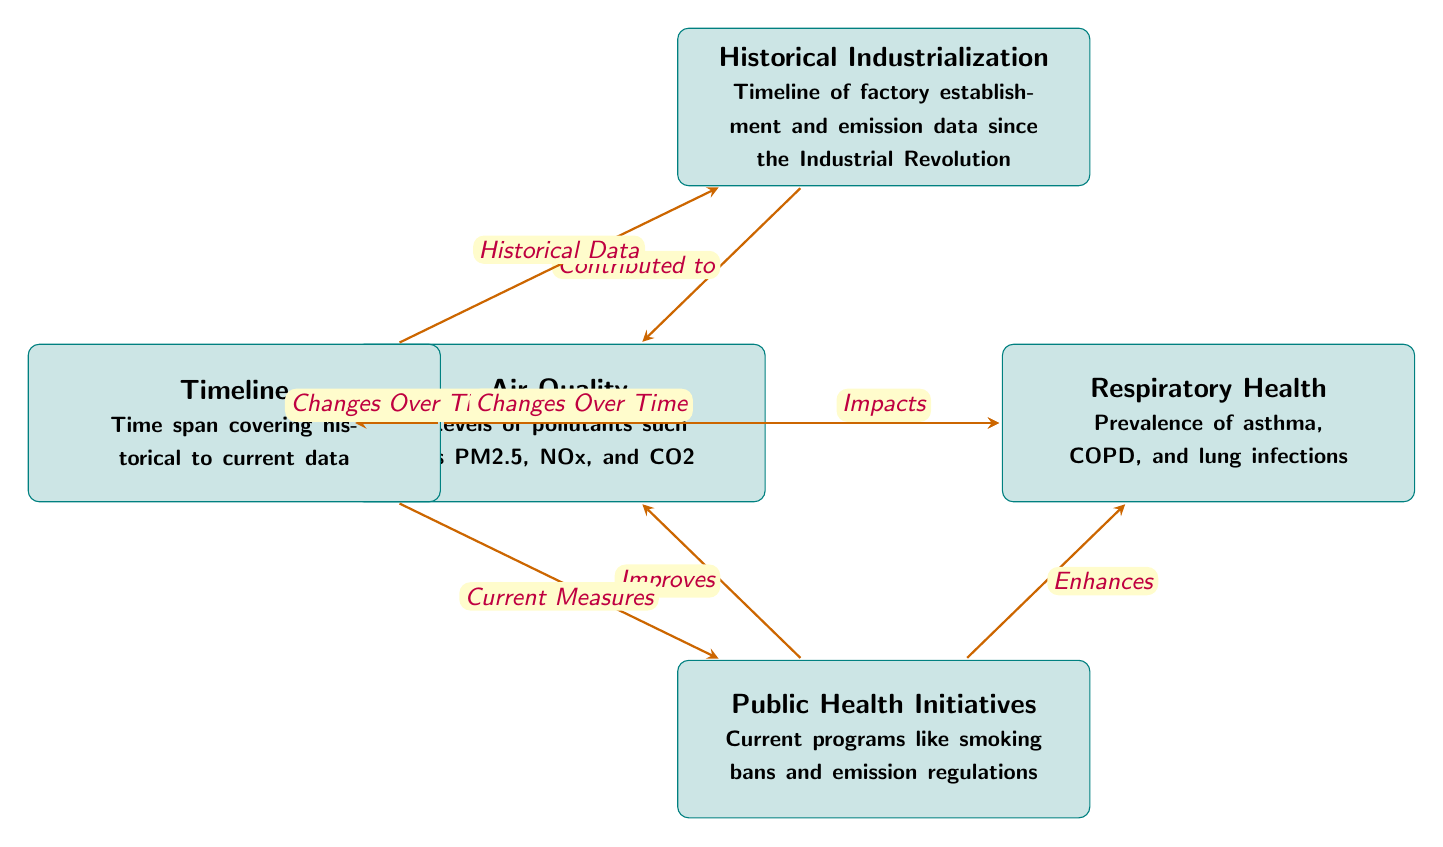What does the "Air Quality" box represent? The "Air Quality" box represents the levels of pollutants such as PM2.5, NOx, and CO2, indicating the primary focus of air quality measurement in relation to health.
Answer: Levels of pollutants such as PM2.5, NOx, and CO2 What is the impact of air quality on respiratory health? The diagram indicates that air quality impacts respiratory health, specifically showing a direct relationship from the "Air Quality" box to the "Respiratory Health" box labeled as "Impacts".
Answer: Impacts How many types of historical data are referenced in the diagram? The diagram references one type of historical data which focuses on the timeline of factory establishment and emission data since the Industrial Revolution.
Answer: One What current programs are mentioned under public health initiatives? The "Public Health Initiatives" box mentions current programs like smoking bans and emission regulations, which are aimed at improving public health.
Answer: Smoking bans and emission regulations How does public health initiatives improve air quality? The relationship from the "Public Health Initiatives" box to the "Air Quality" box indicates that these initiatives are designed to improve air quality, as shown by the arrow labeled "Improves".
Answer: Improves What does the "Historical Industrialization" box refer to? The "Historical Industrialization" box refers to the timeline of factory establishment and emission data since the Industrial Revolution, which is crucial for understanding how industrial activities have contributed to air quality.
Answer: Timeline of factory establishment and emission data How is the timeline relevant to air quality and respiratory health? The diagram shows arrows leading from the "Timeline" box to both "Air Quality" and "Respiratory Health" boxes, indicating that changes over time in both air quality and health outcomes are tracked through this timeline.
Answer: Changes Over Time What are the effects of public health initiatives on respiratory health? The arrow from "Public Health Initiatives" to "Respiratory Health" indicates that these initiatives enhance respiratory health, suggesting an improvement in health outcomes related to respiratory conditions.
Answer: Enhances What does the downward relationship from "Historical Industrialization" show? The downward relationship indicates that historical industrialization has contributed to current air quality levels, showcasing the long-term impact of past industrial activities on air quality.
Answer: Contributed to 